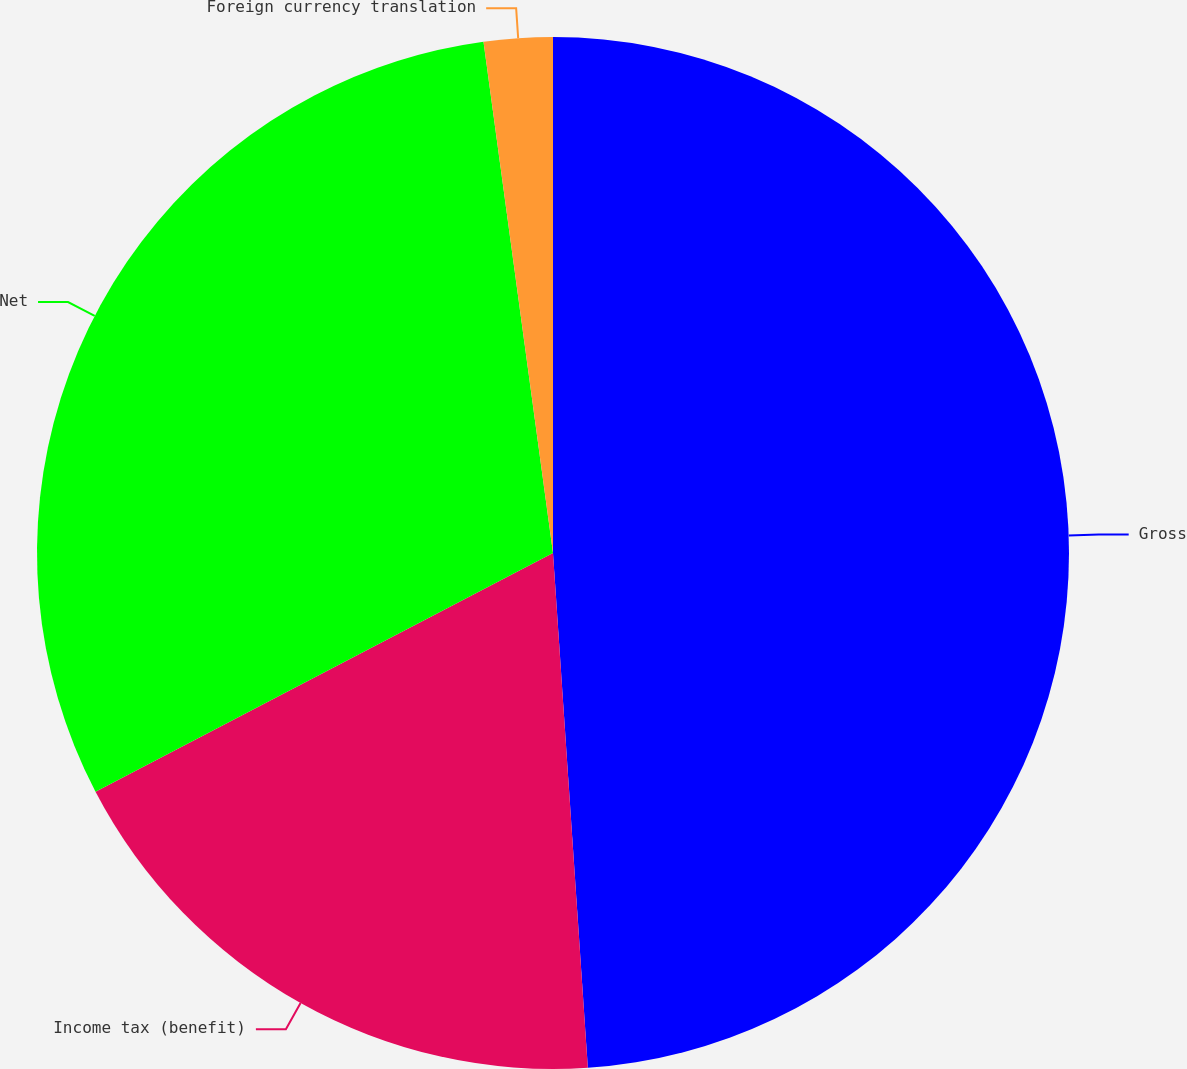Convert chart. <chart><loc_0><loc_0><loc_500><loc_500><pie_chart><fcel>Gross<fcel>Income tax (benefit)<fcel>Net<fcel>Foreign currency translation<nl><fcel>48.92%<fcel>18.42%<fcel>30.5%<fcel>2.15%<nl></chart> 